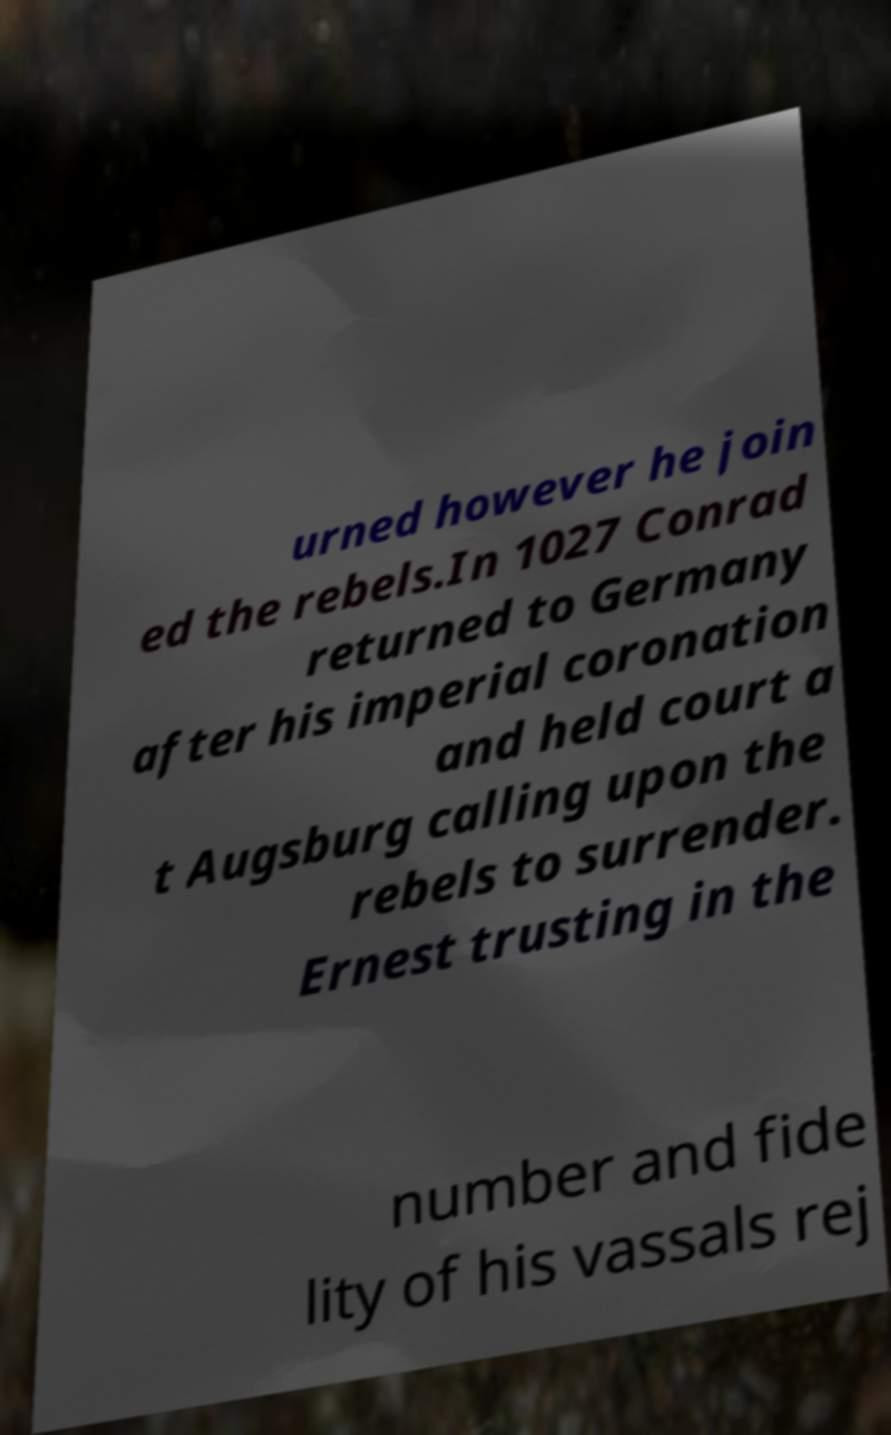What messages or text are displayed in this image? I need them in a readable, typed format. urned however he join ed the rebels.In 1027 Conrad returned to Germany after his imperial coronation and held court a t Augsburg calling upon the rebels to surrender. Ernest trusting in the number and fide lity of his vassals rej 